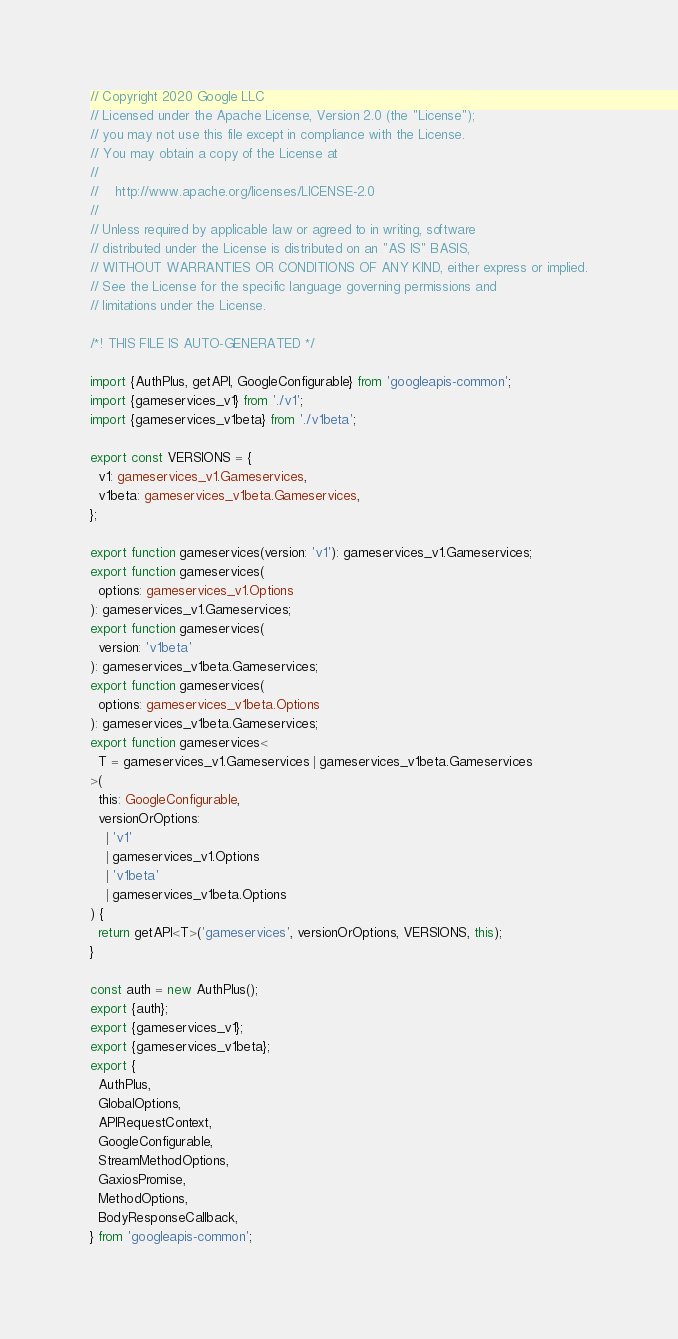<code> <loc_0><loc_0><loc_500><loc_500><_TypeScript_>// Copyright 2020 Google LLC
// Licensed under the Apache License, Version 2.0 (the "License");
// you may not use this file except in compliance with the License.
// You may obtain a copy of the License at
//
//    http://www.apache.org/licenses/LICENSE-2.0
//
// Unless required by applicable law or agreed to in writing, software
// distributed under the License is distributed on an "AS IS" BASIS,
// WITHOUT WARRANTIES OR CONDITIONS OF ANY KIND, either express or implied.
// See the License for the specific language governing permissions and
// limitations under the License.

/*! THIS FILE IS AUTO-GENERATED */

import {AuthPlus, getAPI, GoogleConfigurable} from 'googleapis-common';
import {gameservices_v1} from './v1';
import {gameservices_v1beta} from './v1beta';

export const VERSIONS = {
  v1: gameservices_v1.Gameservices,
  v1beta: gameservices_v1beta.Gameservices,
};

export function gameservices(version: 'v1'): gameservices_v1.Gameservices;
export function gameservices(
  options: gameservices_v1.Options
): gameservices_v1.Gameservices;
export function gameservices(
  version: 'v1beta'
): gameservices_v1beta.Gameservices;
export function gameservices(
  options: gameservices_v1beta.Options
): gameservices_v1beta.Gameservices;
export function gameservices<
  T = gameservices_v1.Gameservices | gameservices_v1beta.Gameservices
>(
  this: GoogleConfigurable,
  versionOrOptions:
    | 'v1'
    | gameservices_v1.Options
    | 'v1beta'
    | gameservices_v1beta.Options
) {
  return getAPI<T>('gameservices', versionOrOptions, VERSIONS, this);
}

const auth = new AuthPlus();
export {auth};
export {gameservices_v1};
export {gameservices_v1beta};
export {
  AuthPlus,
  GlobalOptions,
  APIRequestContext,
  GoogleConfigurable,
  StreamMethodOptions,
  GaxiosPromise,
  MethodOptions,
  BodyResponseCallback,
} from 'googleapis-common';
</code> 